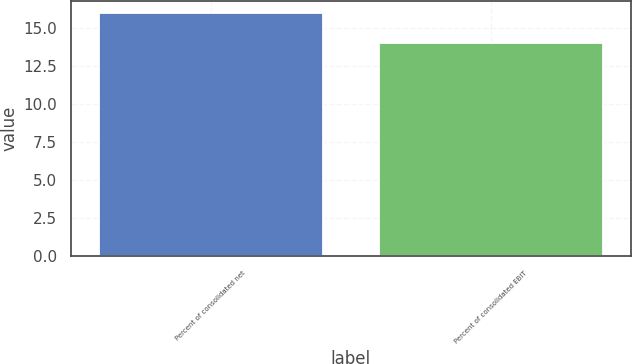<chart> <loc_0><loc_0><loc_500><loc_500><bar_chart><fcel>Percent of consolidated net<fcel>Percent of consolidated EBIT<nl><fcel>16<fcel>14<nl></chart> 